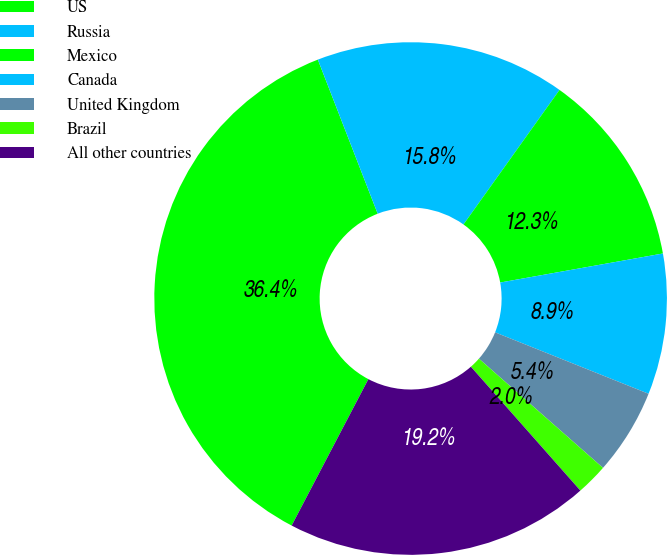Convert chart to OTSL. <chart><loc_0><loc_0><loc_500><loc_500><pie_chart><fcel>US<fcel>Russia<fcel>Mexico<fcel>Canada<fcel>United Kingdom<fcel>Brazil<fcel>All other countries<nl><fcel>36.42%<fcel>15.76%<fcel>12.32%<fcel>8.87%<fcel>5.43%<fcel>1.99%<fcel>19.2%<nl></chart> 